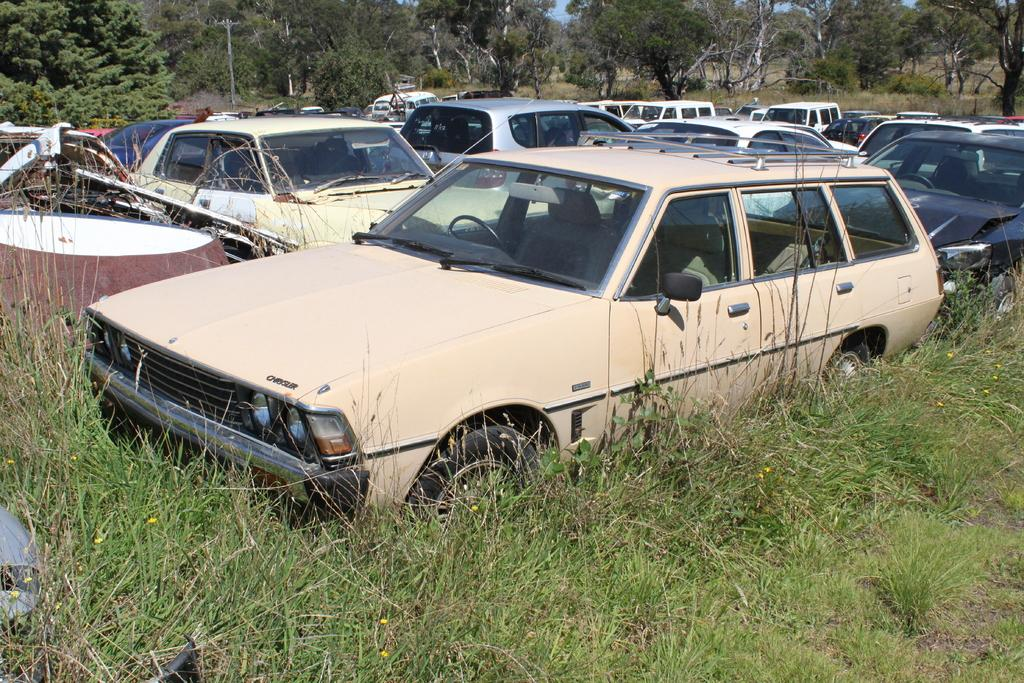What is the unusual location for the vehicles in the image? The vehicles are parked on the grass in the image. Can you describe any other objects present in the image? The facts do not specify any other objects, only that there are objects present. What can be seen in the background of the image? There are trees in the background of the image. What type of carriage can be seen exchanging thoughts with the trees in the image? There is no carriage or exchange of thoughts present in the image; it features vehicles parked on the grass and trees in the background. 